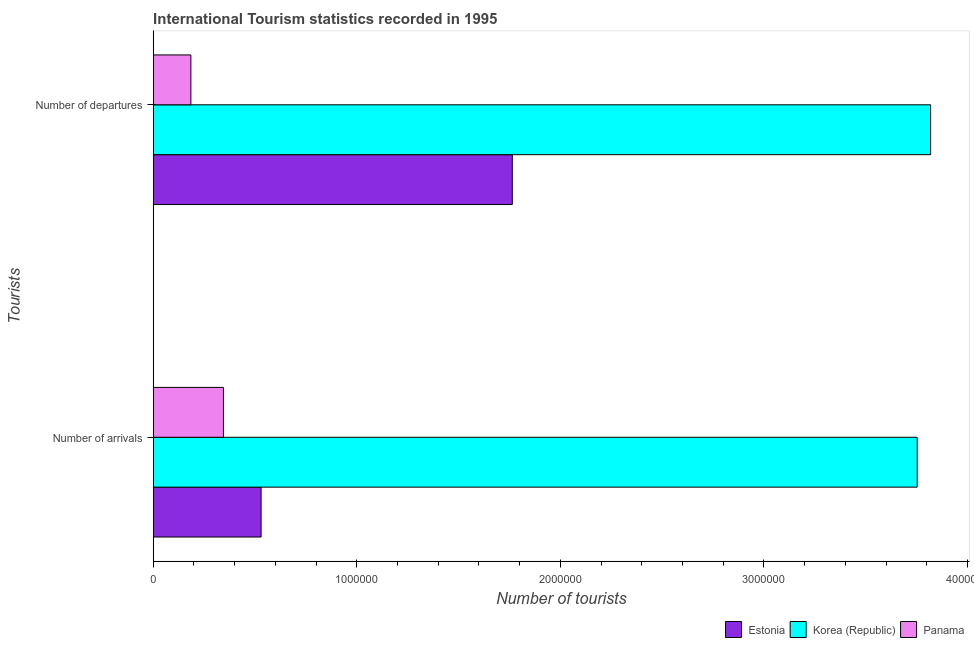How many different coloured bars are there?
Provide a short and direct response. 3. How many groups of bars are there?
Ensure brevity in your answer.  2. Are the number of bars per tick equal to the number of legend labels?
Provide a short and direct response. Yes. What is the label of the 2nd group of bars from the top?
Make the answer very short. Number of arrivals. What is the number of tourist arrivals in Estonia?
Offer a terse response. 5.30e+05. Across all countries, what is the maximum number of tourist departures?
Provide a short and direct response. 3.82e+06. Across all countries, what is the minimum number of tourist arrivals?
Give a very brief answer. 3.45e+05. In which country was the number of tourist arrivals minimum?
Keep it short and to the point. Panama. What is the total number of tourist arrivals in the graph?
Offer a very short reply. 4.63e+06. What is the difference between the number of tourist departures in Estonia and that in Korea (Republic)?
Your answer should be compact. -2.06e+06. What is the difference between the number of tourist arrivals in Estonia and the number of tourist departures in Panama?
Make the answer very short. 3.45e+05. What is the average number of tourist arrivals per country?
Keep it short and to the point. 1.54e+06. What is the difference between the number of tourist arrivals and number of tourist departures in Korea (Republic)?
Ensure brevity in your answer.  -6.60e+04. What is the ratio of the number of tourist arrivals in Estonia to that in Korea (Republic)?
Offer a terse response. 0.14. What does the 3rd bar from the top in Number of arrivals represents?
Your response must be concise. Estonia. What does the 3rd bar from the bottom in Number of departures represents?
Provide a short and direct response. Panama. How many bars are there?
Provide a short and direct response. 6. Are all the bars in the graph horizontal?
Make the answer very short. Yes. How many countries are there in the graph?
Offer a terse response. 3. What is the difference between two consecutive major ticks on the X-axis?
Make the answer very short. 1.00e+06. Does the graph contain grids?
Ensure brevity in your answer.  No. Where does the legend appear in the graph?
Provide a short and direct response. Bottom right. How many legend labels are there?
Make the answer very short. 3. What is the title of the graph?
Give a very brief answer. International Tourism statistics recorded in 1995. Does "High income" appear as one of the legend labels in the graph?
Provide a short and direct response. No. What is the label or title of the X-axis?
Provide a succinct answer. Number of tourists. What is the label or title of the Y-axis?
Your answer should be very brief. Tourists. What is the Number of tourists in Estonia in Number of arrivals?
Your answer should be compact. 5.30e+05. What is the Number of tourists in Korea (Republic) in Number of arrivals?
Keep it short and to the point. 3.75e+06. What is the Number of tourists in Panama in Number of arrivals?
Provide a succinct answer. 3.45e+05. What is the Number of tourists in Estonia in Number of departures?
Provide a short and direct response. 1.76e+06. What is the Number of tourists of Korea (Republic) in Number of departures?
Ensure brevity in your answer.  3.82e+06. What is the Number of tourists of Panama in Number of departures?
Offer a very short reply. 1.85e+05. Across all Tourists, what is the maximum Number of tourists in Estonia?
Ensure brevity in your answer.  1.76e+06. Across all Tourists, what is the maximum Number of tourists in Korea (Republic)?
Offer a very short reply. 3.82e+06. Across all Tourists, what is the maximum Number of tourists in Panama?
Ensure brevity in your answer.  3.45e+05. Across all Tourists, what is the minimum Number of tourists of Estonia?
Offer a terse response. 5.30e+05. Across all Tourists, what is the minimum Number of tourists in Korea (Republic)?
Keep it short and to the point. 3.75e+06. Across all Tourists, what is the minimum Number of tourists in Panama?
Provide a short and direct response. 1.85e+05. What is the total Number of tourists in Estonia in the graph?
Offer a very short reply. 2.29e+06. What is the total Number of tourists in Korea (Republic) in the graph?
Give a very brief answer. 7.57e+06. What is the total Number of tourists in Panama in the graph?
Provide a succinct answer. 5.30e+05. What is the difference between the Number of tourists of Estonia in Number of arrivals and that in Number of departures?
Make the answer very short. -1.23e+06. What is the difference between the Number of tourists of Korea (Republic) in Number of arrivals and that in Number of departures?
Offer a terse response. -6.60e+04. What is the difference between the Number of tourists in Panama in Number of arrivals and that in Number of departures?
Keep it short and to the point. 1.60e+05. What is the difference between the Number of tourists of Estonia in Number of arrivals and the Number of tourists of Korea (Republic) in Number of departures?
Your answer should be very brief. -3.29e+06. What is the difference between the Number of tourists in Estonia in Number of arrivals and the Number of tourists in Panama in Number of departures?
Give a very brief answer. 3.45e+05. What is the difference between the Number of tourists in Korea (Republic) in Number of arrivals and the Number of tourists in Panama in Number of departures?
Make the answer very short. 3.57e+06. What is the average Number of tourists in Estonia per Tourists?
Give a very brief answer. 1.15e+06. What is the average Number of tourists in Korea (Republic) per Tourists?
Your answer should be very brief. 3.79e+06. What is the average Number of tourists in Panama per Tourists?
Give a very brief answer. 2.65e+05. What is the difference between the Number of tourists in Estonia and Number of tourists in Korea (Republic) in Number of arrivals?
Your answer should be very brief. -3.22e+06. What is the difference between the Number of tourists in Estonia and Number of tourists in Panama in Number of arrivals?
Your response must be concise. 1.85e+05. What is the difference between the Number of tourists of Korea (Republic) and Number of tourists of Panama in Number of arrivals?
Give a very brief answer. 3.41e+06. What is the difference between the Number of tourists of Estonia and Number of tourists of Korea (Republic) in Number of departures?
Ensure brevity in your answer.  -2.06e+06. What is the difference between the Number of tourists in Estonia and Number of tourists in Panama in Number of departures?
Offer a terse response. 1.58e+06. What is the difference between the Number of tourists of Korea (Republic) and Number of tourists of Panama in Number of departures?
Make the answer very short. 3.63e+06. What is the ratio of the Number of tourists in Estonia in Number of arrivals to that in Number of departures?
Ensure brevity in your answer.  0.3. What is the ratio of the Number of tourists of Korea (Republic) in Number of arrivals to that in Number of departures?
Offer a very short reply. 0.98. What is the ratio of the Number of tourists in Panama in Number of arrivals to that in Number of departures?
Ensure brevity in your answer.  1.86. What is the difference between the highest and the second highest Number of tourists in Estonia?
Offer a terse response. 1.23e+06. What is the difference between the highest and the second highest Number of tourists in Korea (Republic)?
Keep it short and to the point. 6.60e+04. What is the difference between the highest and the lowest Number of tourists of Estonia?
Your answer should be very brief. 1.23e+06. What is the difference between the highest and the lowest Number of tourists of Korea (Republic)?
Give a very brief answer. 6.60e+04. 